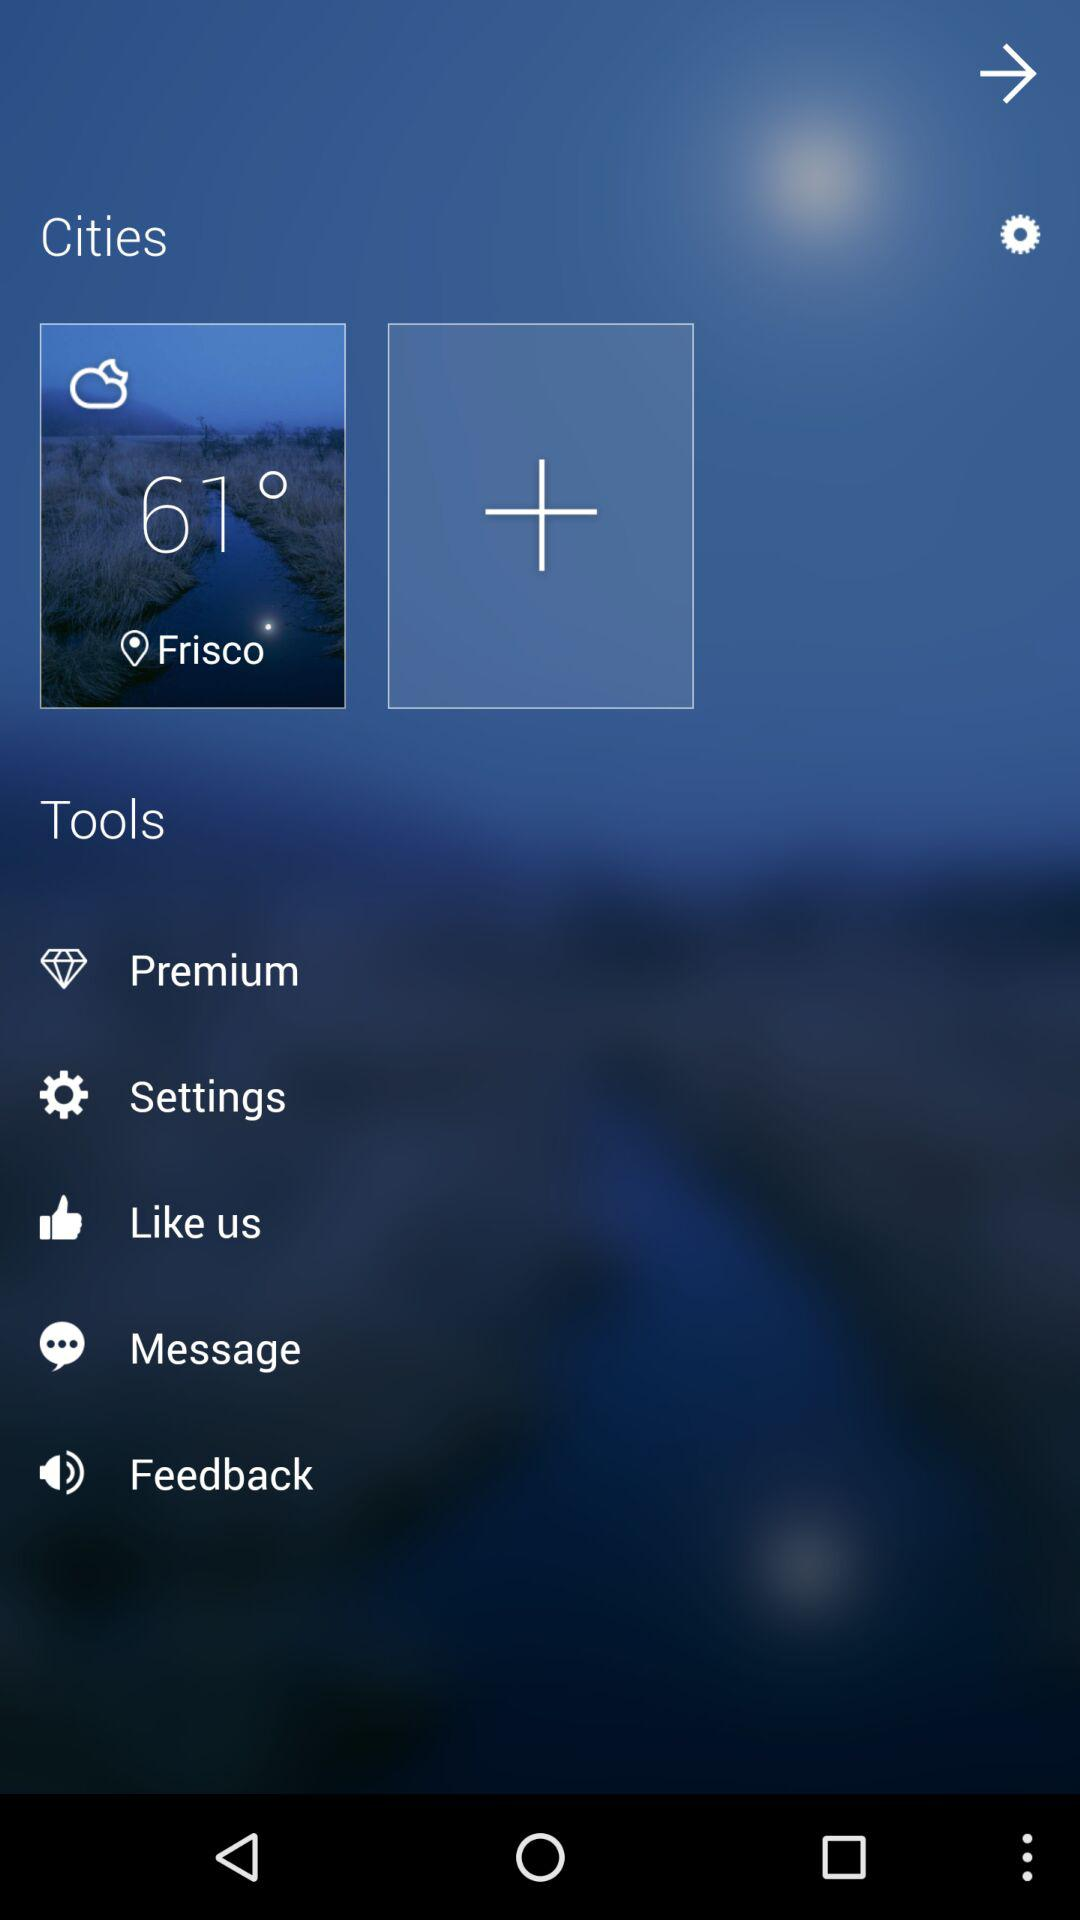What is the temperature at Frisco? The temperature is 61°. 